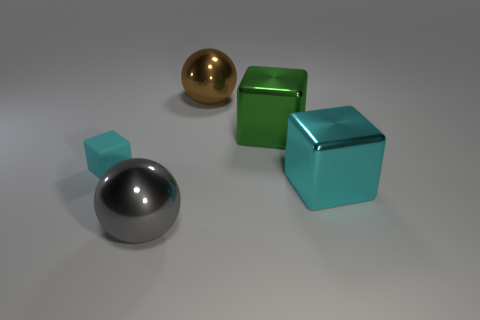What is the relative positioning of the objects in the image? The objects are arranged in a way that shows their relative sizes and positions to each other. The large green cube is in the center-right, with the small reflective turquoise cube in front of it. To the left and slightly behind the large cube is the large chrome sphere, and in the far-left foreground is the small matte turquoise sphere. 